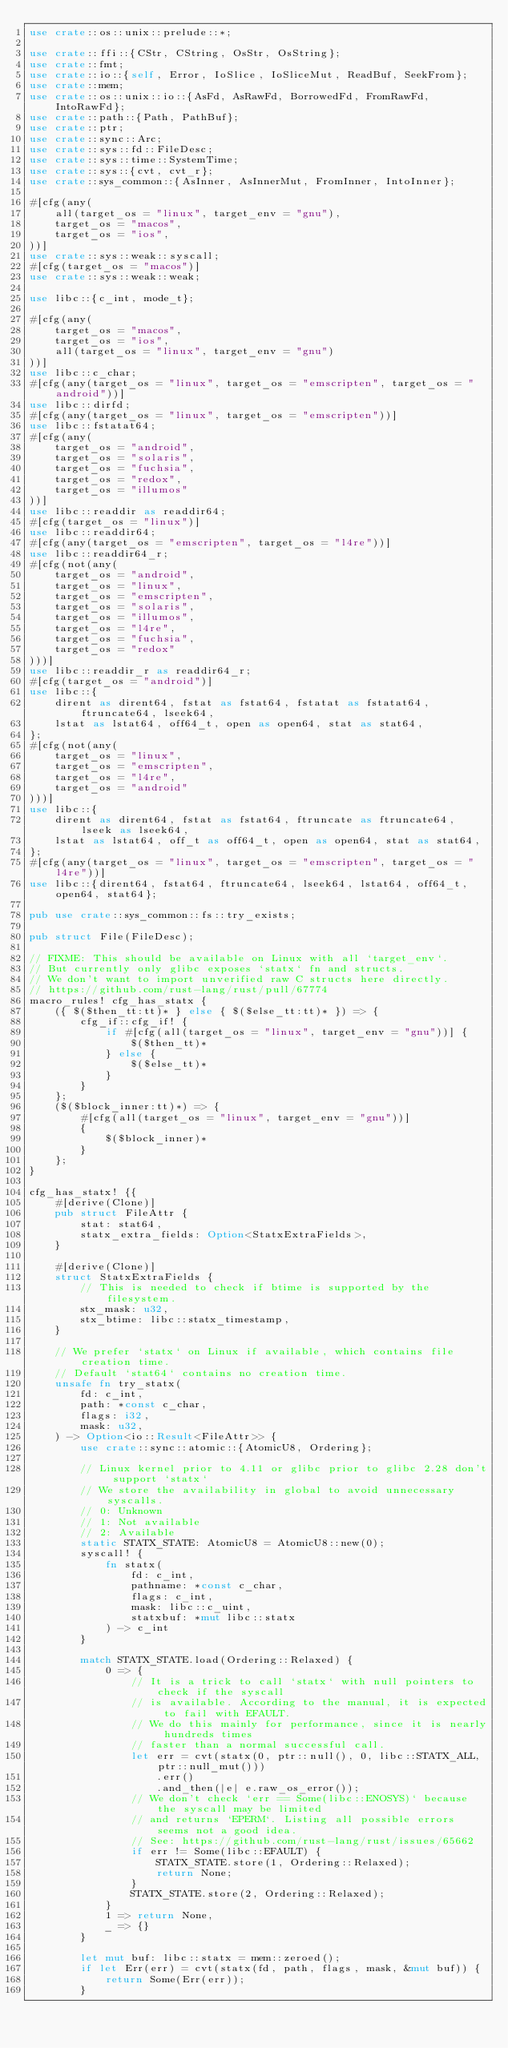<code> <loc_0><loc_0><loc_500><loc_500><_Rust_>use crate::os::unix::prelude::*;

use crate::ffi::{CStr, CString, OsStr, OsString};
use crate::fmt;
use crate::io::{self, Error, IoSlice, IoSliceMut, ReadBuf, SeekFrom};
use crate::mem;
use crate::os::unix::io::{AsFd, AsRawFd, BorrowedFd, FromRawFd, IntoRawFd};
use crate::path::{Path, PathBuf};
use crate::ptr;
use crate::sync::Arc;
use crate::sys::fd::FileDesc;
use crate::sys::time::SystemTime;
use crate::sys::{cvt, cvt_r};
use crate::sys_common::{AsInner, AsInnerMut, FromInner, IntoInner};

#[cfg(any(
    all(target_os = "linux", target_env = "gnu"),
    target_os = "macos",
    target_os = "ios",
))]
use crate::sys::weak::syscall;
#[cfg(target_os = "macos")]
use crate::sys::weak::weak;

use libc::{c_int, mode_t};

#[cfg(any(
    target_os = "macos",
    target_os = "ios",
    all(target_os = "linux", target_env = "gnu")
))]
use libc::c_char;
#[cfg(any(target_os = "linux", target_os = "emscripten", target_os = "android"))]
use libc::dirfd;
#[cfg(any(target_os = "linux", target_os = "emscripten"))]
use libc::fstatat64;
#[cfg(any(
    target_os = "android",
    target_os = "solaris",
    target_os = "fuchsia",
    target_os = "redox",
    target_os = "illumos"
))]
use libc::readdir as readdir64;
#[cfg(target_os = "linux")]
use libc::readdir64;
#[cfg(any(target_os = "emscripten", target_os = "l4re"))]
use libc::readdir64_r;
#[cfg(not(any(
    target_os = "android",
    target_os = "linux",
    target_os = "emscripten",
    target_os = "solaris",
    target_os = "illumos",
    target_os = "l4re",
    target_os = "fuchsia",
    target_os = "redox"
)))]
use libc::readdir_r as readdir64_r;
#[cfg(target_os = "android")]
use libc::{
    dirent as dirent64, fstat as fstat64, fstatat as fstatat64, ftruncate64, lseek64,
    lstat as lstat64, off64_t, open as open64, stat as stat64,
};
#[cfg(not(any(
    target_os = "linux",
    target_os = "emscripten",
    target_os = "l4re",
    target_os = "android"
)))]
use libc::{
    dirent as dirent64, fstat as fstat64, ftruncate as ftruncate64, lseek as lseek64,
    lstat as lstat64, off_t as off64_t, open as open64, stat as stat64,
};
#[cfg(any(target_os = "linux", target_os = "emscripten", target_os = "l4re"))]
use libc::{dirent64, fstat64, ftruncate64, lseek64, lstat64, off64_t, open64, stat64};

pub use crate::sys_common::fs::try_exists;

pub struct File(FileDesc);

// FIXME: This should be available on Linux with all `target_env`.
// But currently only glibc exposes `statx` fn and structs.
// We don't want to import unverified raw C structs here directly.
// https://github.com/rust-lang/rust/pull/67774
macro_rules! cfg_has_statx {
    ({ $($then_tt:tt)* } else { $($else_tt:tt)* }) => {
        cfg_if::cfg_if! {
            if #[cfg(all(target_os = "linux", target_env = "gnu"))] {
                $($then_tt)*
            } else {
                $($else_tt)*
            }
        }
    };
    ($($block_inner:tt)*) => {
        #[cfg(all(target_os = "linux", target_env = "gnu"))]
        {
            $($block_inner)*
        }
    };
}

cfg_has_statx! {{
    #[derive(Clone)]
    pub struct FileAttr {
        stat: stat64,
        statx_extra_fields: Option<StatxExtraFields>,
    }

    #[derive(Clone)]
    struct StatxExtraFields {
        // This is needed to check if btime is supported by the filesystem.
        stx_mask: u32,
        stx_btime: libc::statx_timestamp,
    }

    // We prefer `statx` on Linux if available, which contains file creation time.
    // Default `stat64` contains no creation time.
    unsafe fn try_statx(
        fd: c_int,
        path: *const c_char,
        flags: i32,
        mask: u32,
    ) -> Option<io::Result<FileAttr>> {
        use crate::sync::atomic::{AtomicU8, Ordering};

        // Linux kernel prior to 4.11 or glibc prior to glibc 2.28 don't support `statx`
        // We store the availability in global to avoid unnecessary syscalls.
        // 0: Unknown
        // 1: Not available
        // 2: Available
        static STATX_STATE: AtomicU8 = AtomicU8::new(0);
        syscall! {
            fn statx(
                fd: c_int,
                pathname: *const c_char,
                flags: c_int,
                mask: libc::c_uint,
                statxbuf: *mut libc::statx
            ) -> c_int
        }

        match STATX_STATE.load(Ordering::Relaxed) {
            0 => {
                // It is a trick to call `statx` with null pointers to check if the syscall
                // is available. According to the manual, it is expected to fail with EFAULT.
                // We do this mainly for performance, since it is nearly hundreds times
                // faster than a normal successful call.
                let err = cvt(statx(0, ptr::null(), 0, libc::STATX_ALL, ptr::null_mut()))
                    .err()
                    .and_then(|e| e.raw_os_error());
                // We don't check `err == Some(libc::ENOSYS)` because the syscall may be limited
                // and returns `EPERM`. Listing all possible errors seems not a good idea.
                // See: https://github.com/rust-lang/rust/issues/65662
                if err != Some(libc::EFAULT) {
                    STATX_STATE.store(1, Ordering::Relaxed);
                    return None;
                }
                STATX_STATE.store(2, Ordering::Relaxed);
            }
            1 => return None,
            _ => {}
        }

        let mut buf: libc::statx = mem::zeroed();
        if let Err(err) = cvt(statx(fd, path, flags, mask, &mut buf)) {
            return Some(Err(err));
        }
</code> 